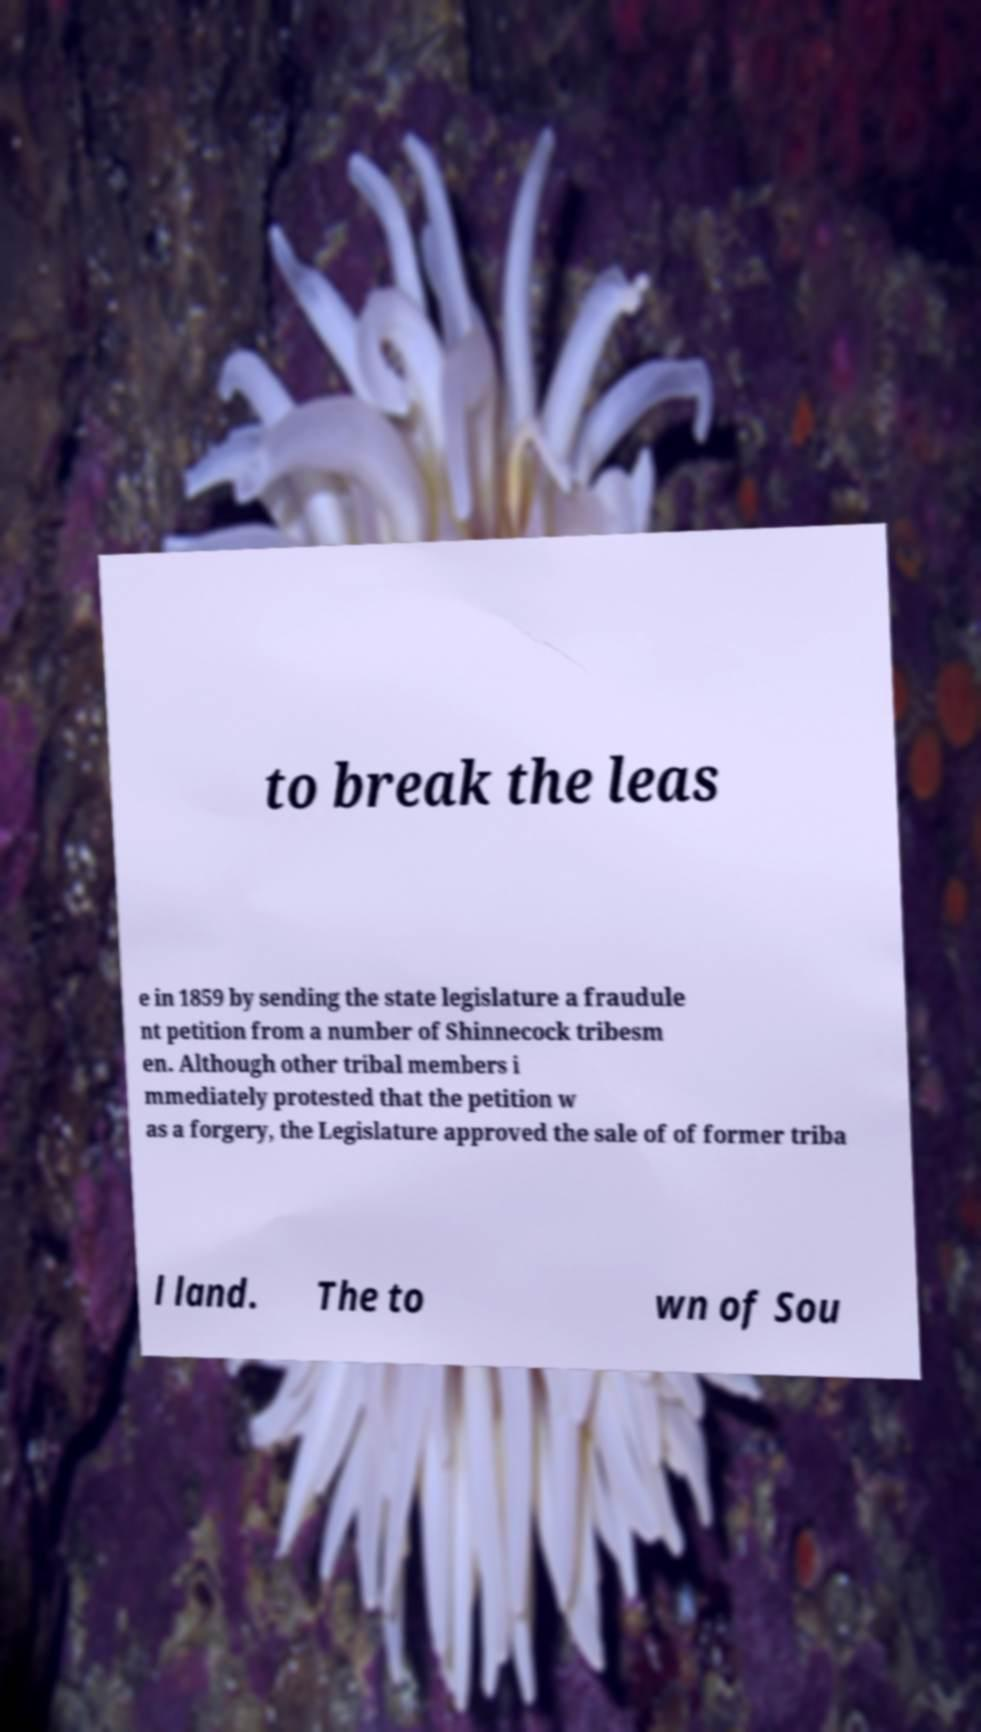Could you extract and type out the text from this image? to break the leas e in 1859 by sending the state legislature a fraudule nt petition from a number of Shinnecock tribesm en. Although other tribal members i mmediately protested that the petition w as a forgery, the Legislature approved the sale of of former triba l land. The to wn of Sou 